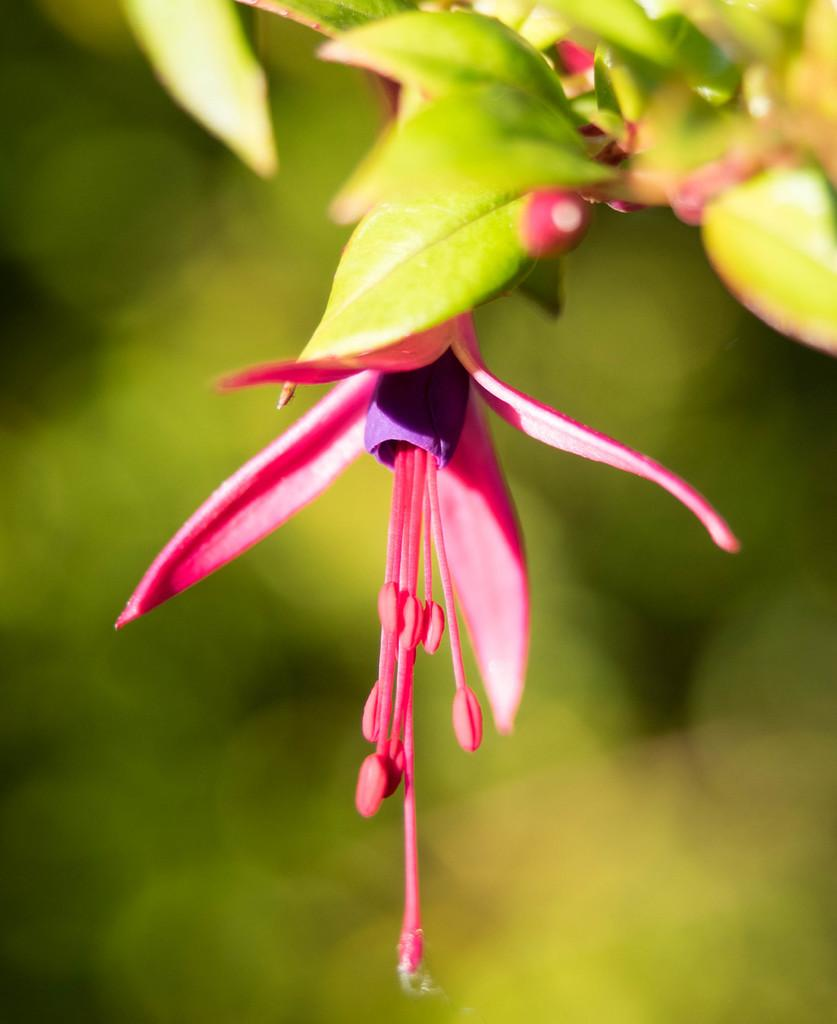What type of plant element is present in the image? There is a flower in the image. What other plant elements can be seen in the image besides the flower? There are leaves in the image. What type of loaf is being exchanged between the geese in the image? There are no geese or loaves present in the image; it only features a flower and leaves. 